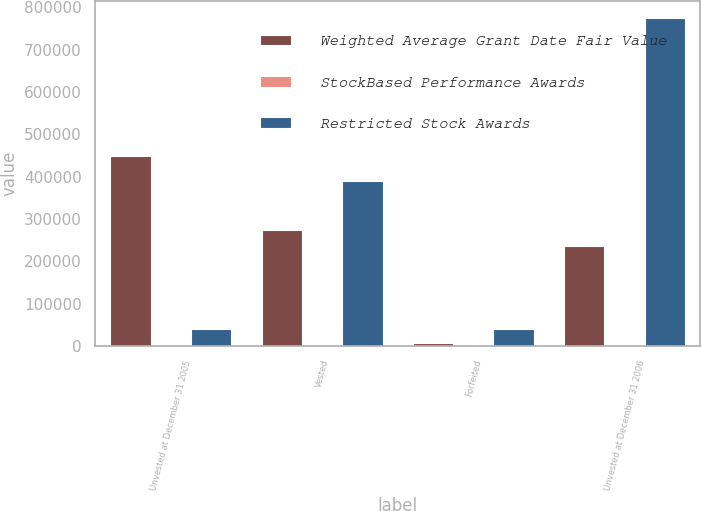Convert chart to OTSL. <chart><loc_0><loc_0><loc_500><loc_500><stacked_bar_chart><ecel><fcel>Unvested at December 31 2005<fcel>Vested<fcel>Forfeited<fcel>Unvested at December 31 2006<nl><fcel>Weighted Average Grant Date Fair Value<fcel>448600<fcel>273448<fcel>6000<fcel>237000<nl><fcel>StockBased Performance Awards<fcel>29.93<fcel>38.3<fcel>33.61<fcel>33.61<nl><fcel>Restricted Stock Awards<fcel>39790<fcel>388597<fcel>39790<fcel>776149<nl></chart> 